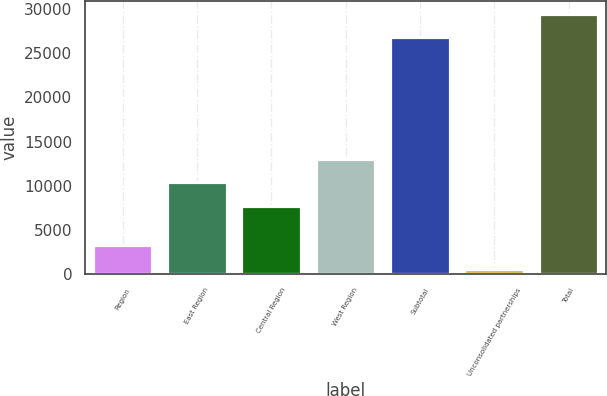<chart> <loc_0><loc_0><loc_500><loc_500><bar_chart><fcel>Region<fcel>East Region<fcel>Central Region<fcel>West Region<fcel>Subtotal<fcel>Unconsolidated partnerships<fcel>Total<nl><fcel>3250.5<fcel>10381.5<fcel>7699<fcel>13064<fcel>26825<fcel>568<fcel>29507.5<nl></chart> 